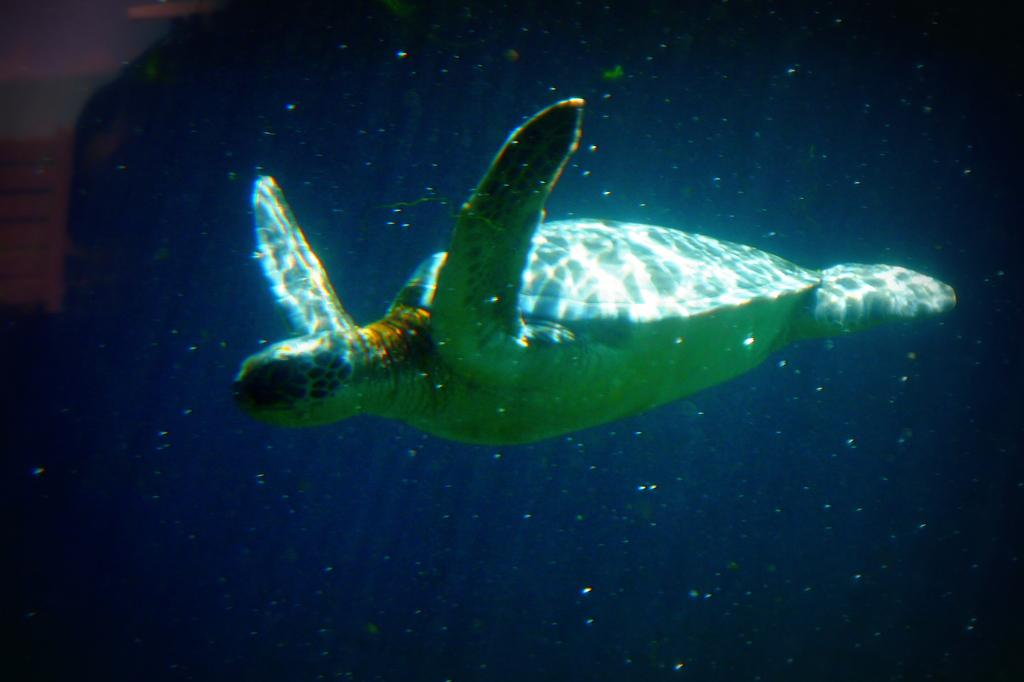What animal is present in the image? There is a tortoise in the image. Where is the tortoise located? The tortoise is in the water. How many buildings can be seen in the image? There are no buildings present in the image; it features a tortoise in the water. What type of powder is visible in the image? There is no powder present in the image. 